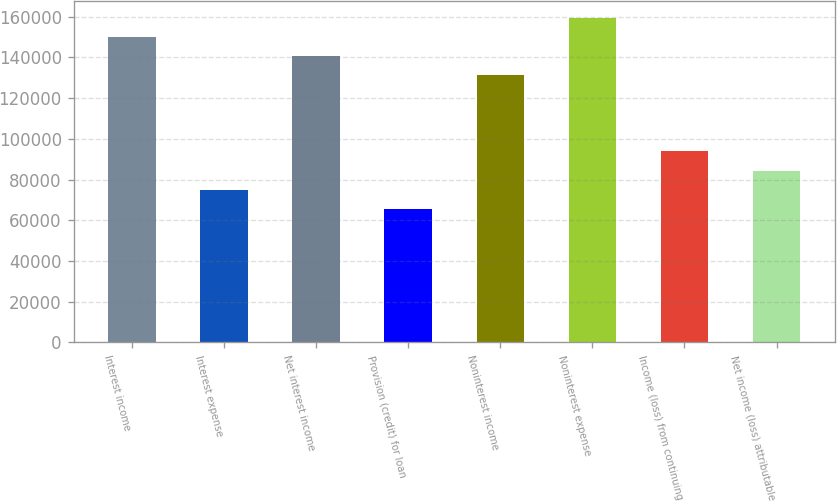<chart> <loc_0><loc_0><loc_500><loc_500><bar_chart><fcel>Interest income<fcel>Interest expense<fcel>Net interest income<fcel>Provision (credit) for loan<fcel>Noninterest income<fcel>Noninterest expense<fcel>Income (loss) from continuing<fcel>Net income (loss) attributable<nl><fcel>150113<fcel>75056.9<fcel>140731<fcel>65674.8<fcel>131349<fcel>159496<fcel>93821<fcel>84438.9<nl></chart> 